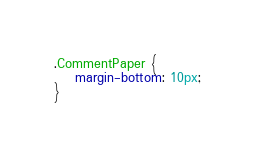Convert code to text. <code><loc_0><loc_0><loc_500><loc_500><_CSS_>
.CommentPaper {
    margin-bottom: 10px;
}</code> 